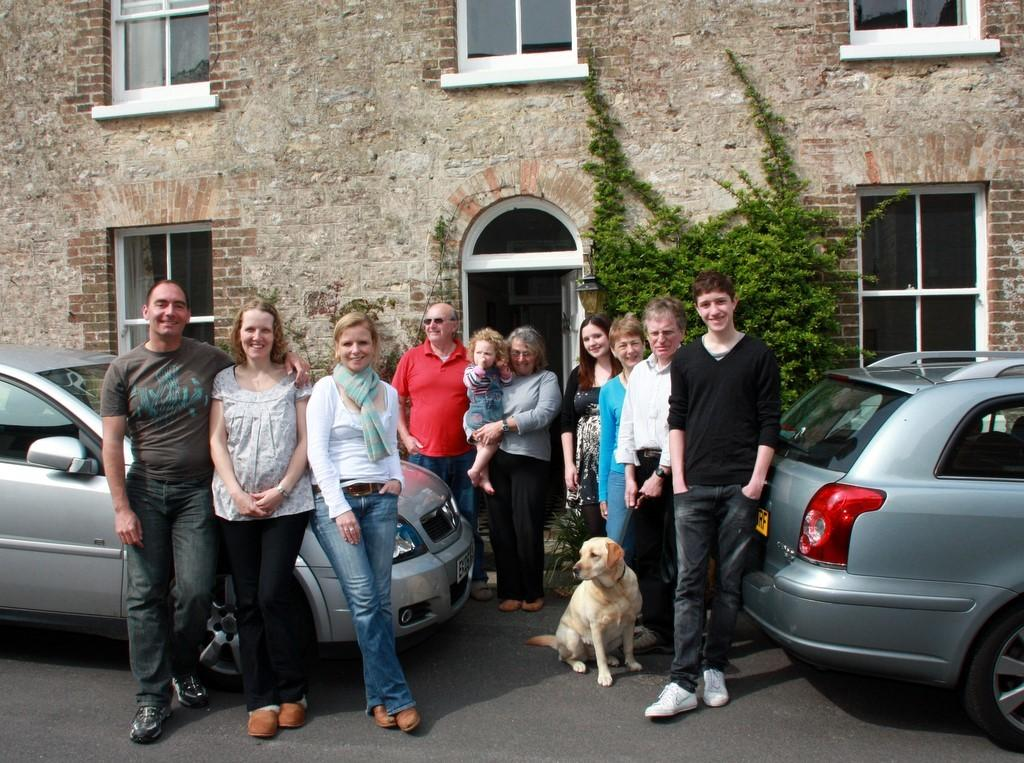What is happening in the image involving people? There are people standing in the image. What can be seen on the road in the image? There are two cars parked on the road and a dog sitting on the road. What is located behind the parked cars? There is a building behind the cars. Is the dog stuck in quicksand on the road in the image? No, there is no quicksand present in the image, and the dog is sitting on the road. Can you hear the dog coughing in the image? There is no sound in the image, so it is impossible to determine if the dog is coughing or not. 